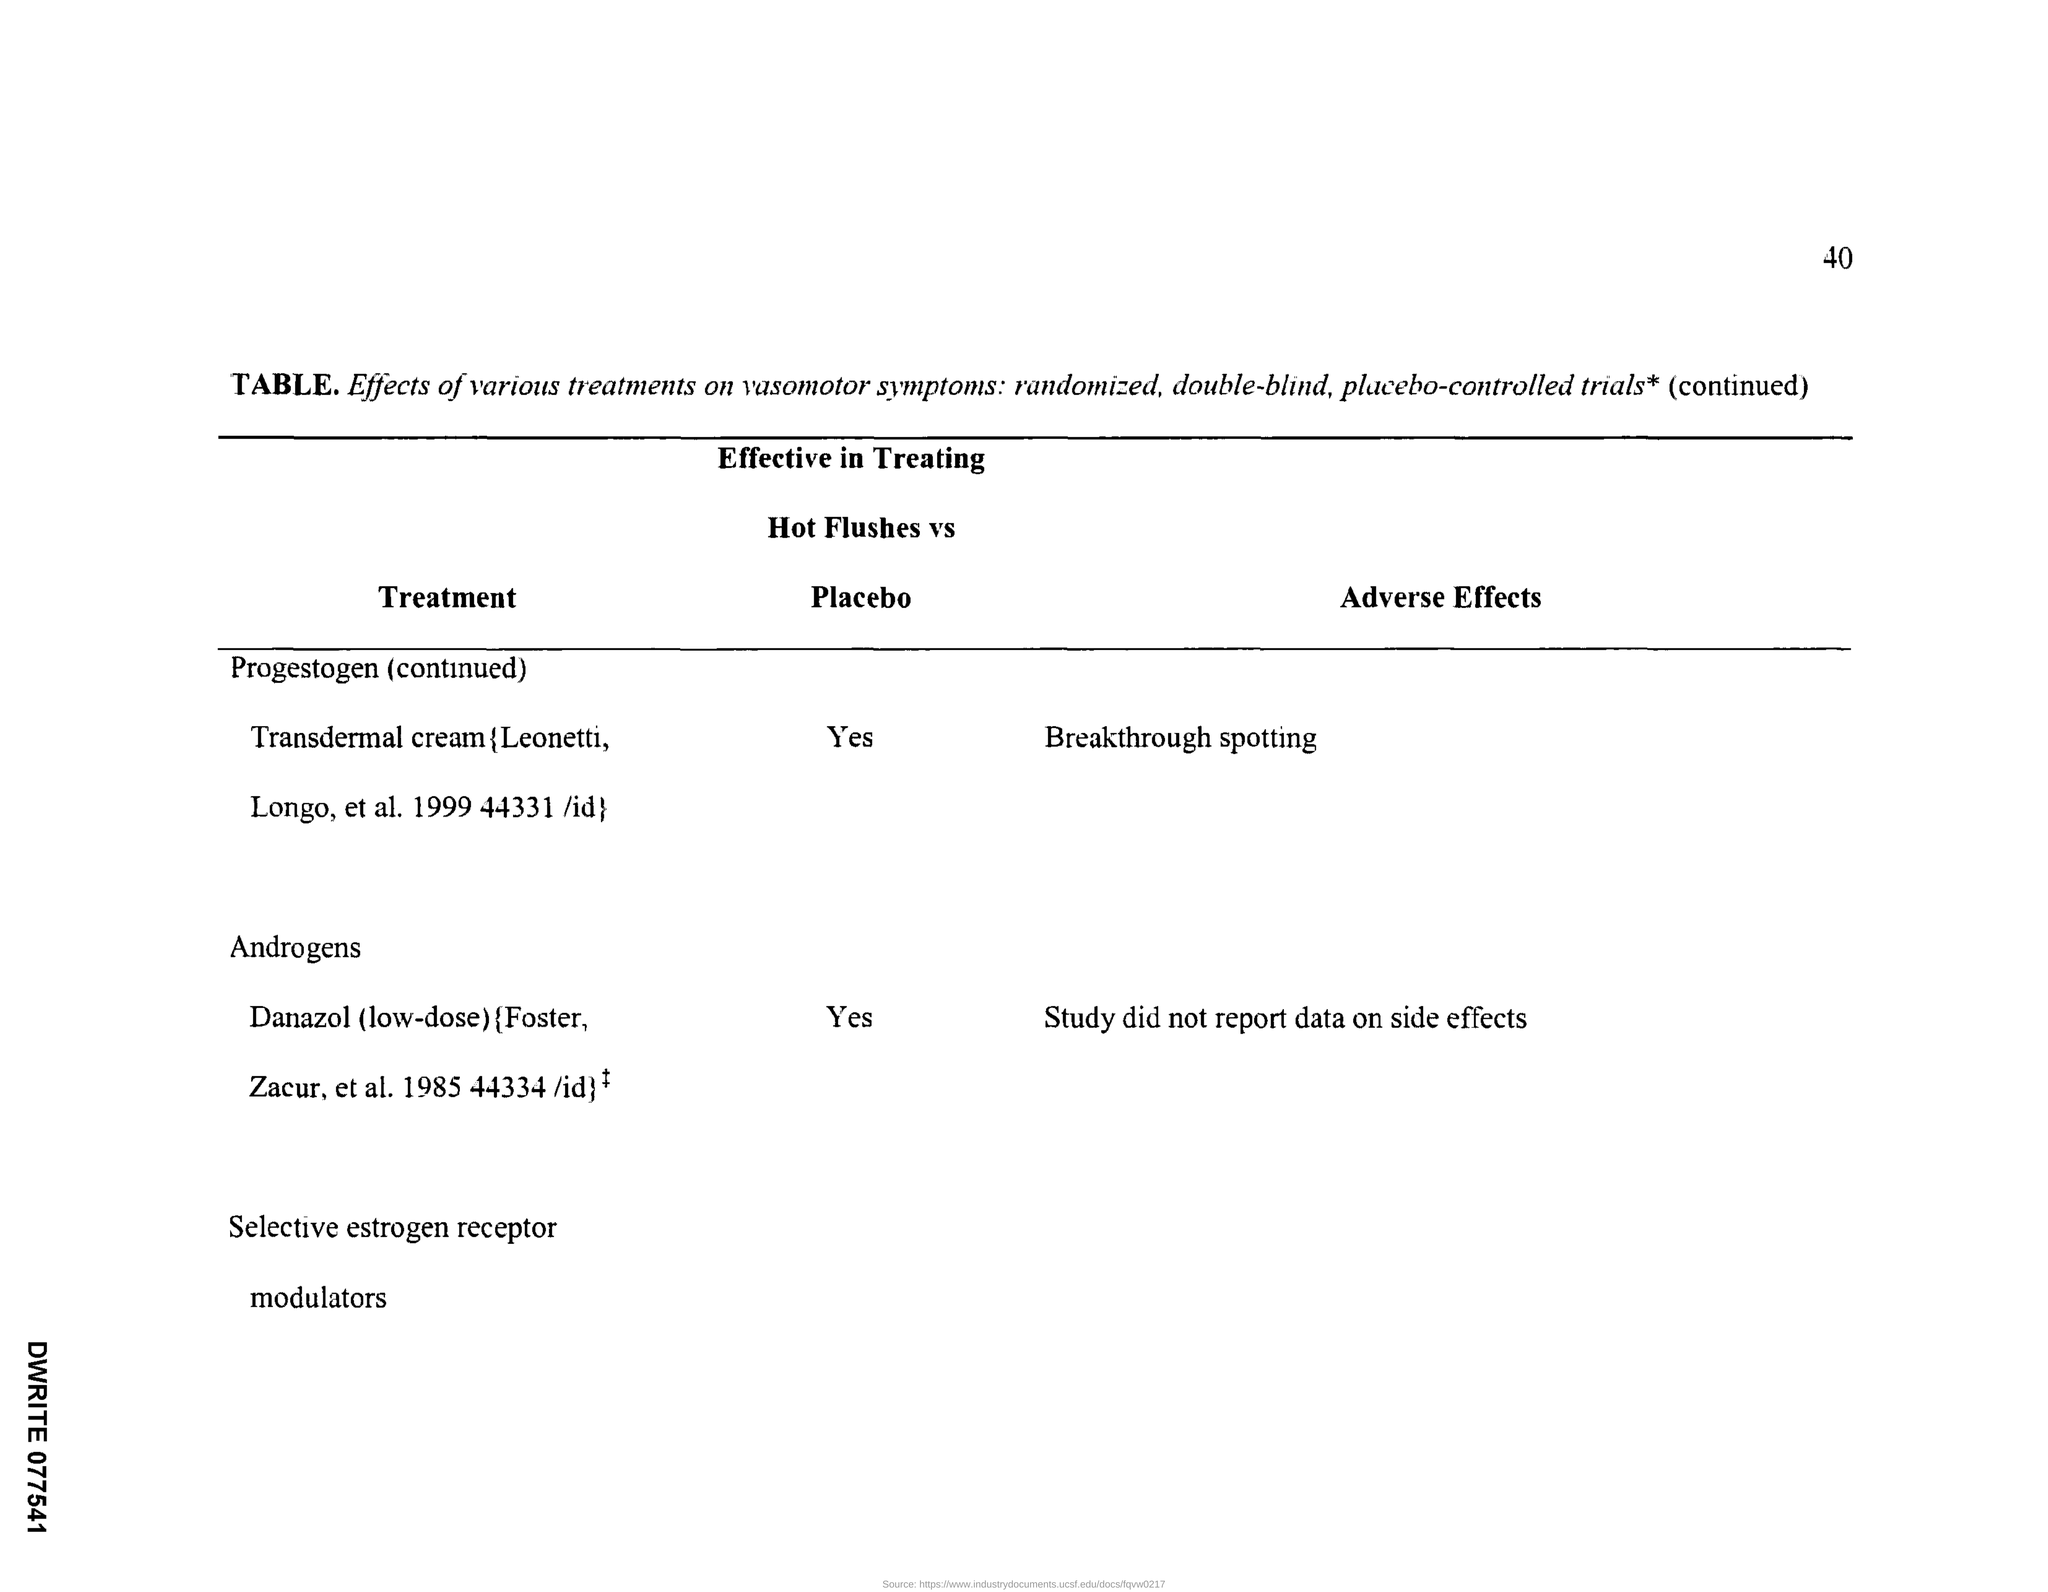Point out several critical features in this image. The third column of the "Table" is given the heading "Adverse Effects. The page number at the top right corner of the page is 40. The second column of the "Table" is given the heading "Effective in treating Hot Flushes vs Placebo. The heading given to the first column of the "Table" is "Treatment. The adverse effects of progestogen treatment can include breakthrough spotting. 